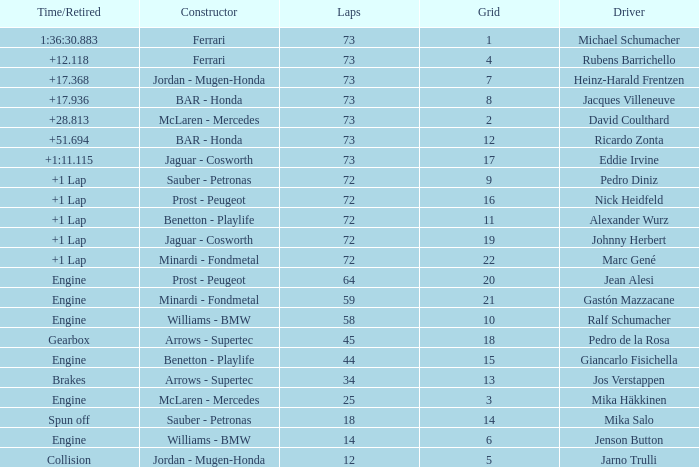How many laps did Jos Verstappen do on Grid 2? 34.0. 